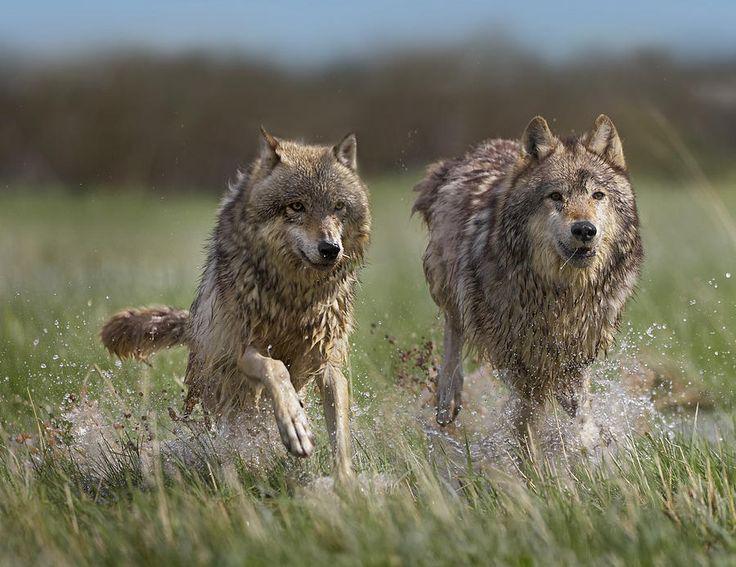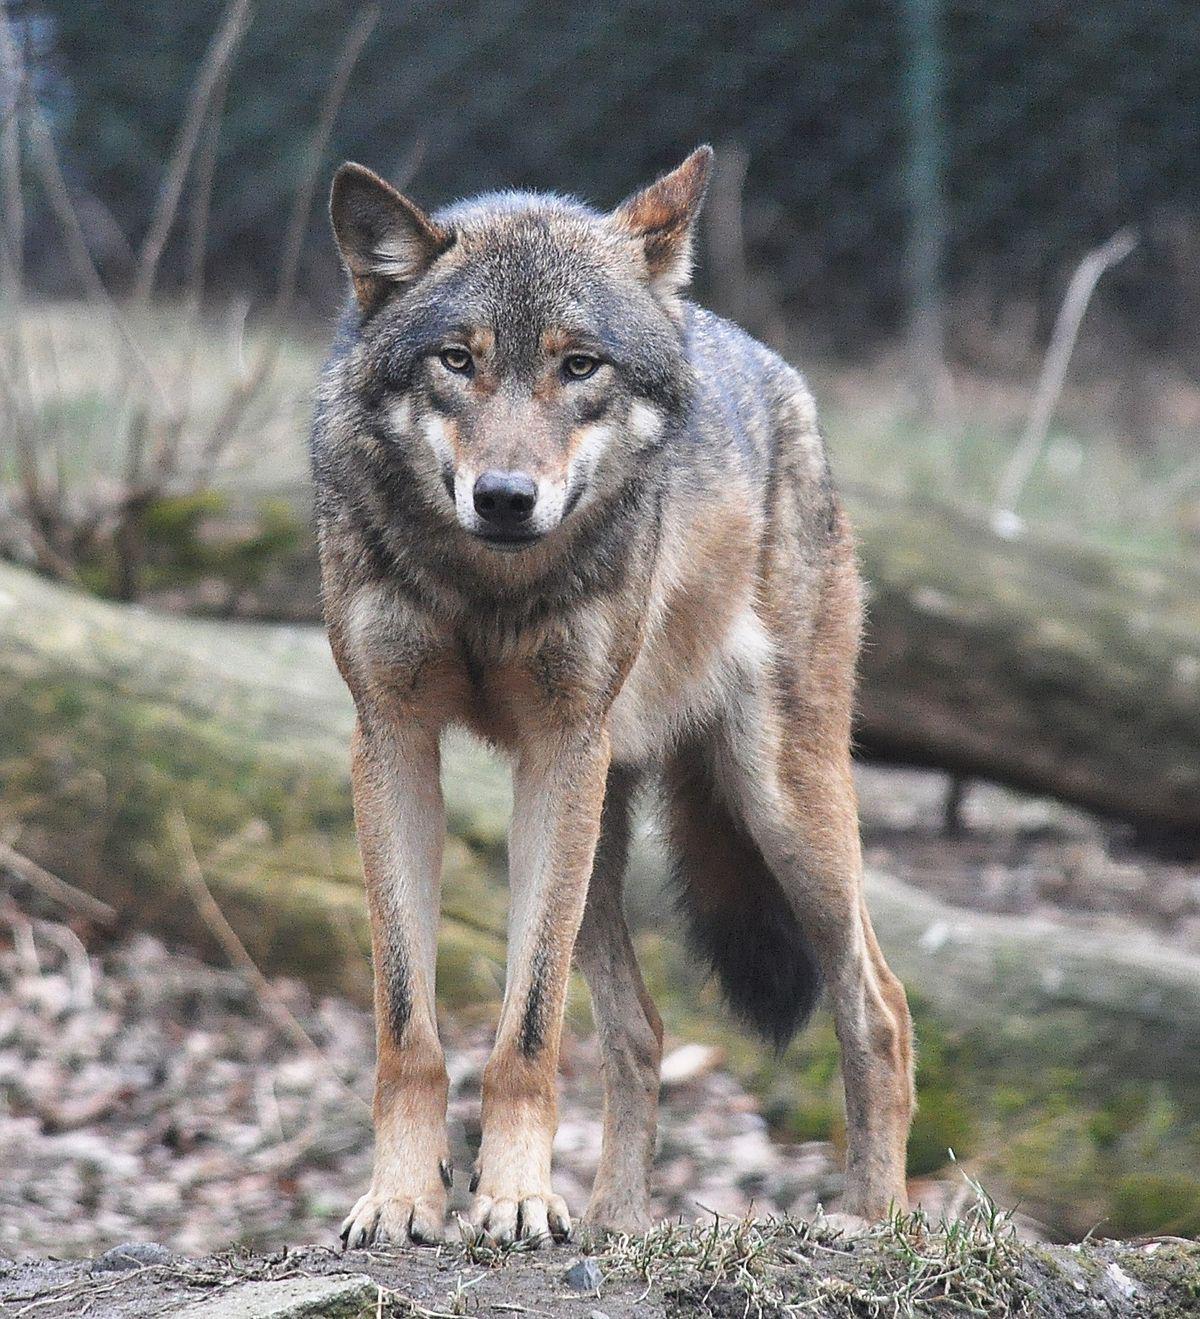The first image is the image on the left, the second image is the image on the right. Evaluate the accuracy of this statement regarding the images: "There are two wolves". Is it true? Answer yes or no. No. 